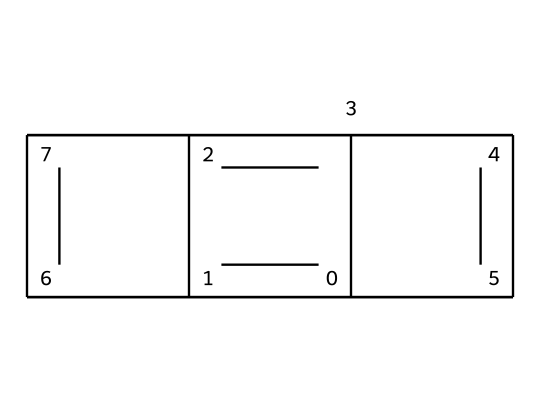What is the molecular formula of this graphite lubricant? To determine the molecular formula, we need to identify the types and counts of atoms visible in the SMILES representation. The SMILES suggests a cyclic structure made of carbon atoms exclusively. Counting the 'C' atoms gives us 20 carbon atoms while there are no other elements present. Thus, the molecular formula is C20.
Answer: C20 How many rings are present in the structure? From analyzing the SMILES notation, I can visually identify the bonds and the structure itself. This structure contains multiple bonds indicating rings due to the connected cycles. By closely inspecting, I can conclude there are five rings sharing carbon atoms.
Answer: five What is the primary use of this compound in mechanical pencils? The primary use of graphite, which is what this compound represents, is as a lubricant or core material. Graphite provides a smooth writing experience because of its layered structure that allows sheets to slide over one another easily.
Answer: lubricant Does this compound have any functional groups? A functional group typically consists of certain groups of atoms that confer specific properties to the compound. In analyzing the provided structure, it is clear that this particular SMILES notation does not demonstrate any functional groups like hydroxyl or carboxyl; it is primarily comprised of carbon atoms.
Answer: no Is this compound solid at room temperature? Given the context of graphite's properties, it is known for being a solid at room temperature. Its physical attributes contribute to its function as a lubricant, and it maintains this state under standard conditions.
Answer: yes 